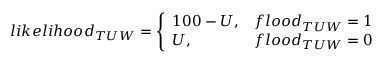Convert formula to latex. <formula><loc_0><loc_0><loc_500><loc_500>l i k e l i h o o d _ { T U W } = \left \{ \begin{array} { l l } { 1 0 0 - U , } & { f l o o d _ { T U W } = 1 } \\ { U , } & { f l o o d _ { T U W } = 0 } \end{array}</formula> 